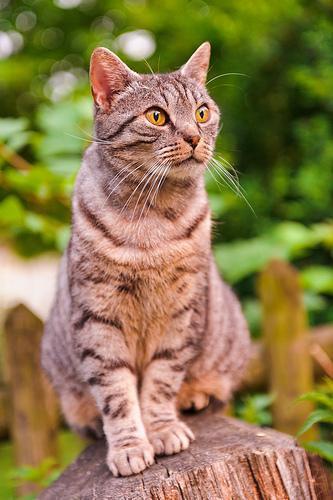How many cats in picture?
Give a very brief answer. 1. 